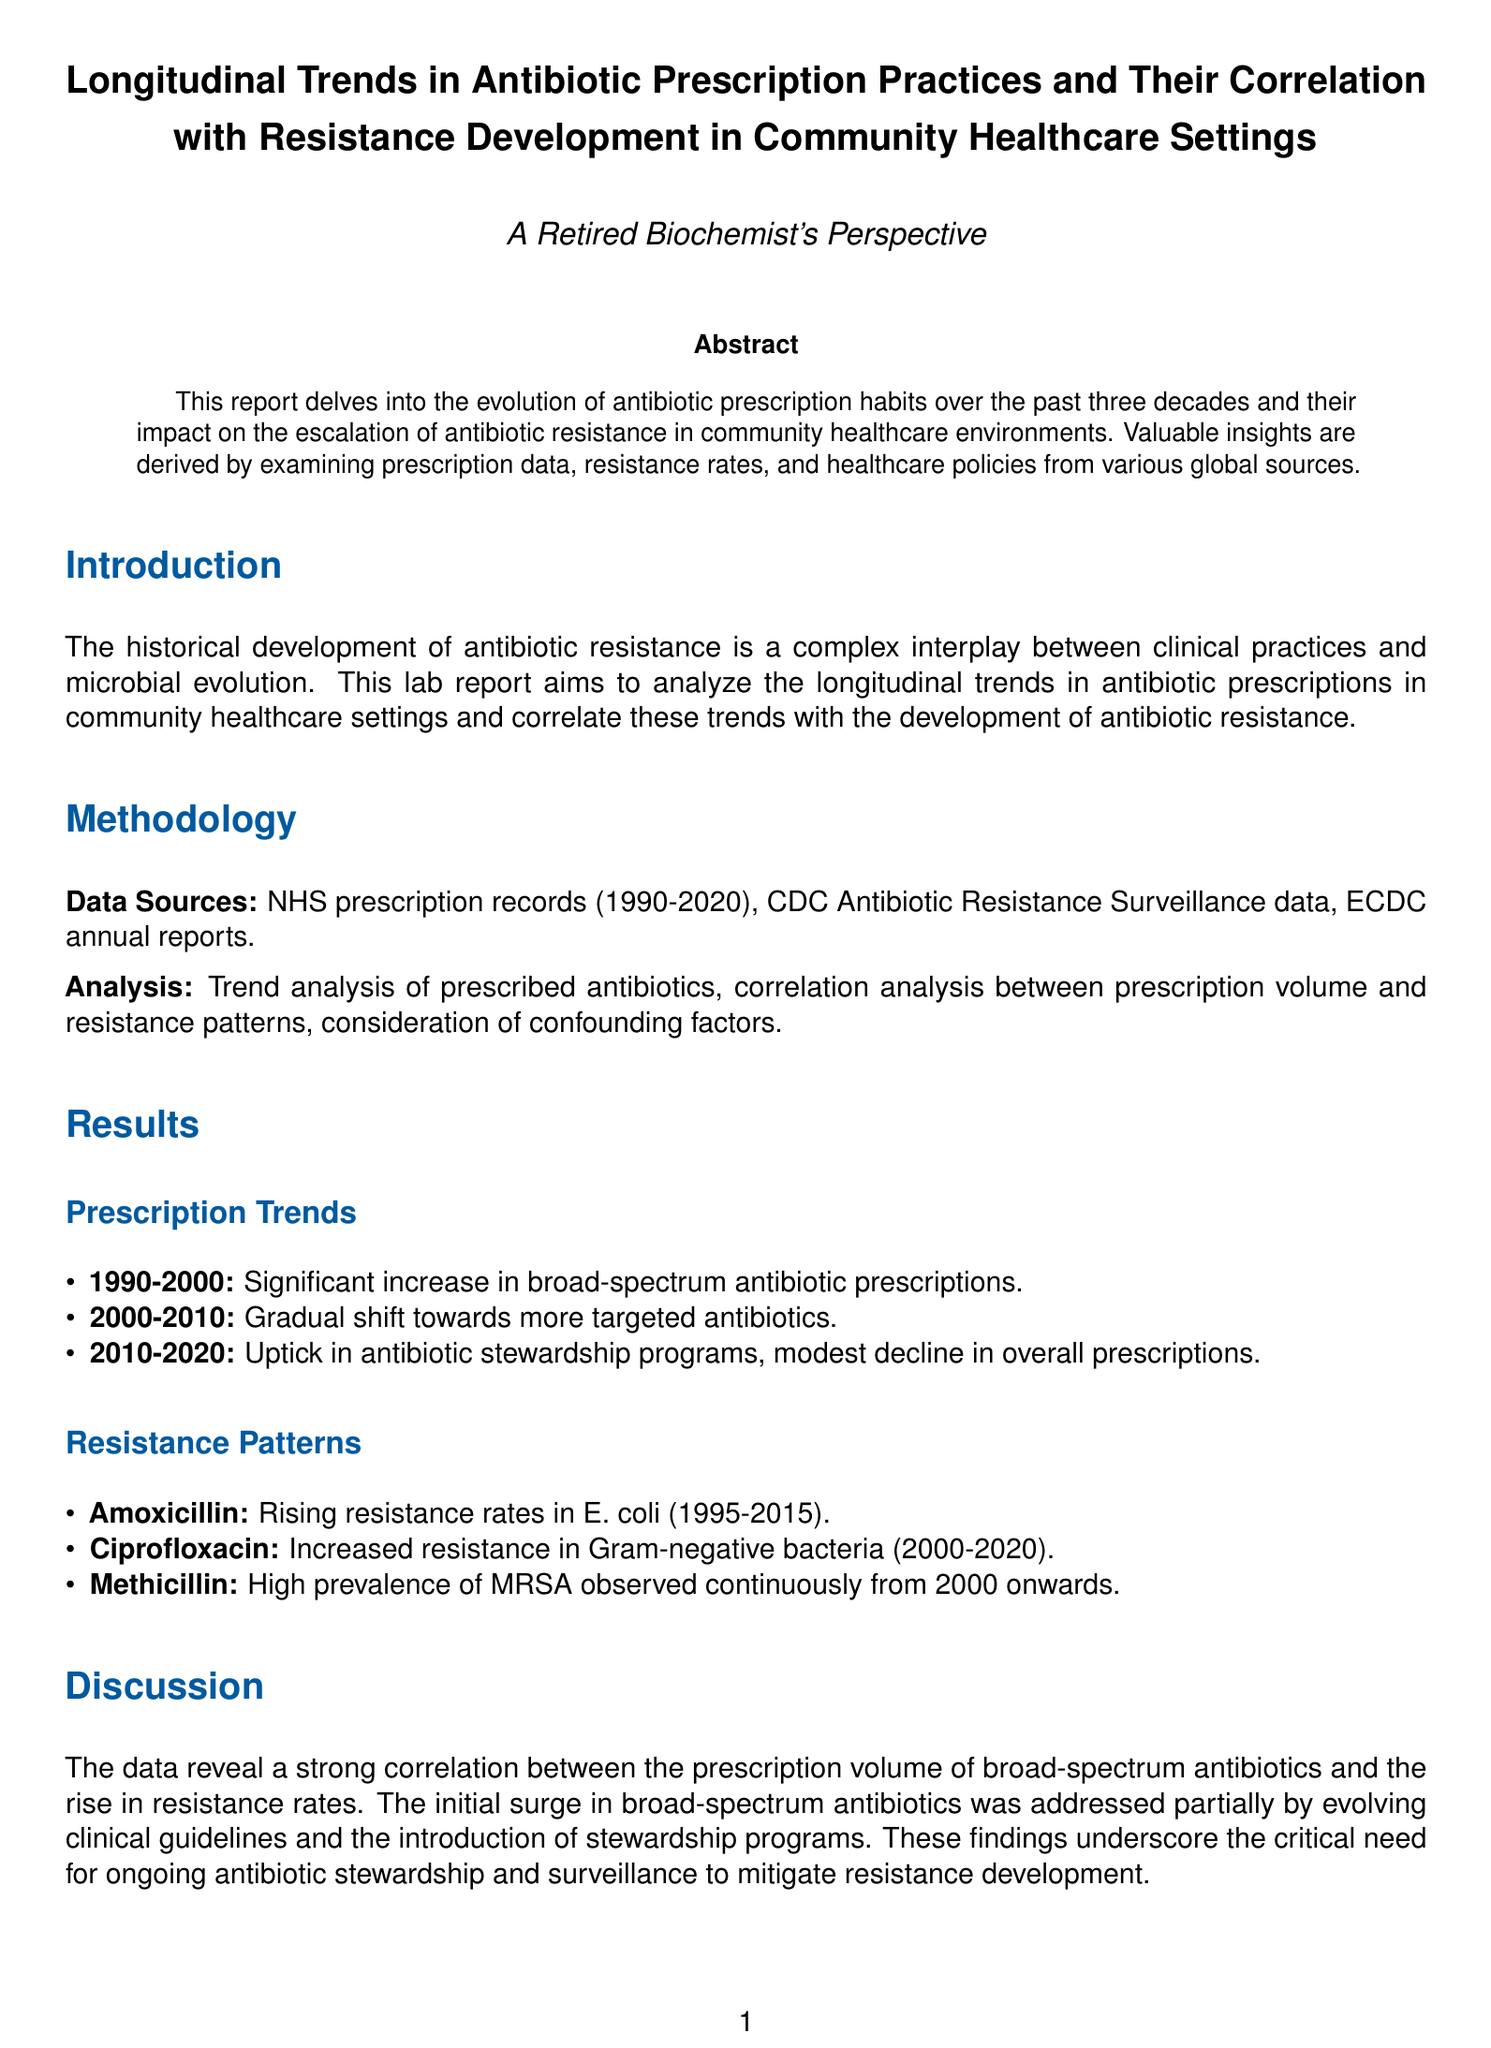what is the time span of the data analyzed? The document mentions that data from the years 1990 to 2020 was examined, indicating a three-decade period of analysis.
Answer: 1990-2020 which antibiotic showed rising resistance rates in E. coli? The report specifically highlights Amoxicillin as showing increasing resistance rates in E. coli from 1995 to 2015.
Answer: Amoxicillin what was a significant change in antibiotic prescriptions during 2000-2010? The report states there was a gradual shift towards more targeted antibiotics during this decade.
Answer: Targeted antibiotics when were antibiotic stewardship programs introduced? According to the results, the uptick in antibiotic stewardship programs occurred from 2010 onwards.
Answer: 2010 which type of bacteria showed increased resistance to Ciprofloxacin? The report notes that Gram-negative bacteria demonstrated increased resistance to Ciprofloxacin between 2000 and 2020.
Answer: Gram-negative bacteria what is the main conclusion regarding prescription practices? The conclusion emphasizes that inappropriate prescription practices have significantly contributed to the rise of antibiotic resistance.
Answer: Inappropriate prescription practices how did stewardship programs affect resistance development? The results indicated that enhanced stewardship programs showed some efficacy in curbing resistance development.
Answer: Showed some efficacy what does MRSA stand for? In the context of the report, MRSA refers to Methicillin-resistant Staphylococcus aureus, which is a specific type of bacteria noted for its high prevalence.
Answer: Methicillin-resistant Staphylococcus aureus 